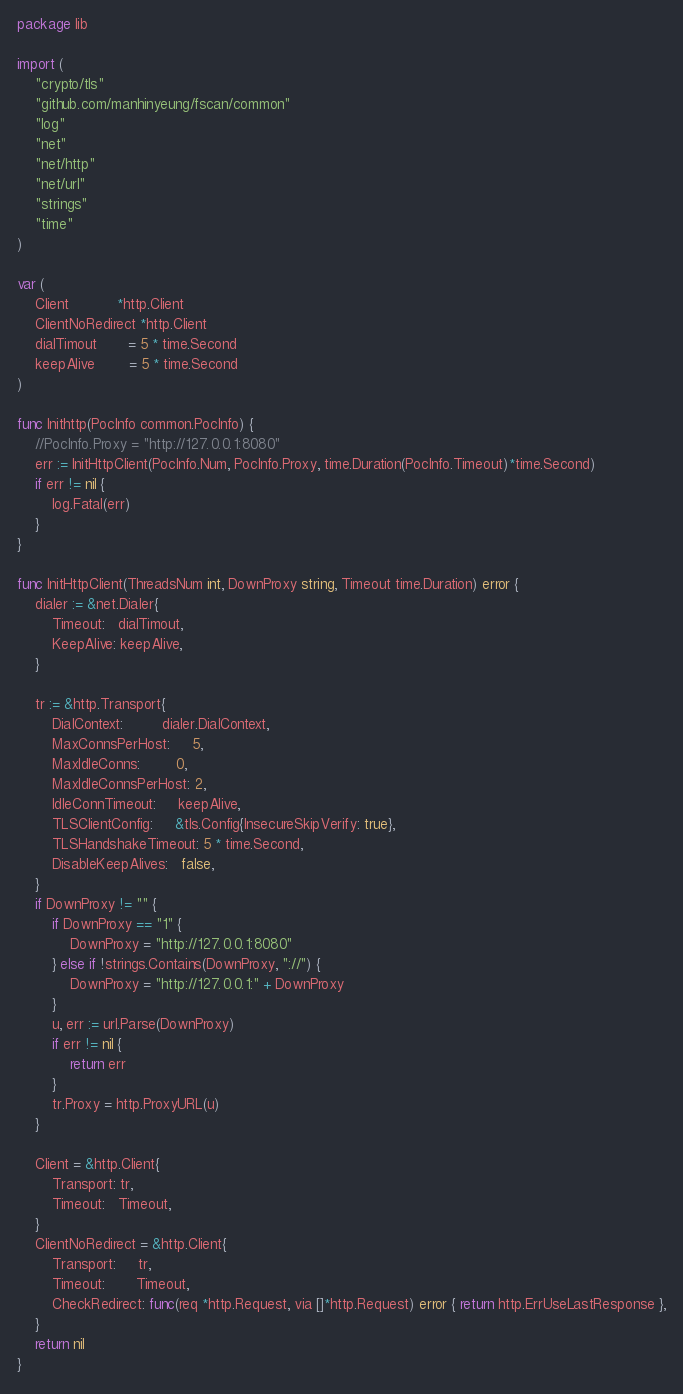Convert code to text. <code><loc_0><loc_0><loc_500><loc_500><_Go_>package lib

import (
	"crypto/tls"
	"github.com/manhinyeung/fscan/common"
	"log"
	"net"
	"net/http"
	"net/url"
	"strings"
	"time"
)

var (
	Client           *http.Client
	ClientNoRedirect *http.Client
	dialTimout       = 5 * time.Second
	keepAlive        = 5 * time.Second
)

func Inithttp(PocInfo common.PocInfo) {
	//PocInfo.Proxy = "http://127.0.0.1:8080"
	err := InitHttpClient(PocInfo.Num, PocInfo.Proxy, time.Duration(PocInfo.Timeout)*time.Second)
	if err != nil {
		log.Fatal(err)
	}
}

func InitHttpClient(ThreadsNum int, DownProxy string, Timeout time.Duration) error {
	dialer := &net.Dialer{
		Timeout:   dialTimout,
		KeepAlive: keepAlive,
	}

	tr := &http.Transport{
		DialContext:         dialer.DialContext,
		MaxConnsPerHost:     5,
		MaxIdleConns:        0,
		MaxIdleConnsPerHost: 2,
		IdleConnTimeout:     keepAlive,
		TLSClientConfig:     &tls.Config{InsecureSkipVerify: true},
		TLSHandshakeTimeout: 5 * time.Second,
		DisableKeepAlives:   false,
	}
	if DownProxy != "" {
		if DownProxy == "1" {
			DownProxy = "http://127.0.0.1:8080"
		} else if !strings.Contains(DownProxy, "://") {
			DownProxy = "http://127.0.0.1:" + DownProxy
		}
		u, err := url.Parse(DownProxy)
		if err != nil {
			return err
		}
		tr.Proxy = http.ProxyURL(u)
	}

	Client = &http.Client{
		Transport: tr,
		Timeout:   Timeout,
	}
	ClientNoRedirect = &http.Client{
		Transport:     tr,
		Timeout:       Timeout,
		CheckRedirect: func(req *http.Request, via []*http.Request) error { return http.ErrUseLastResponse },
	}
	return nil
}
</code> 